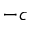<formula> <loc_0><loc_0><loc_500><loc_500>- c</formula> 